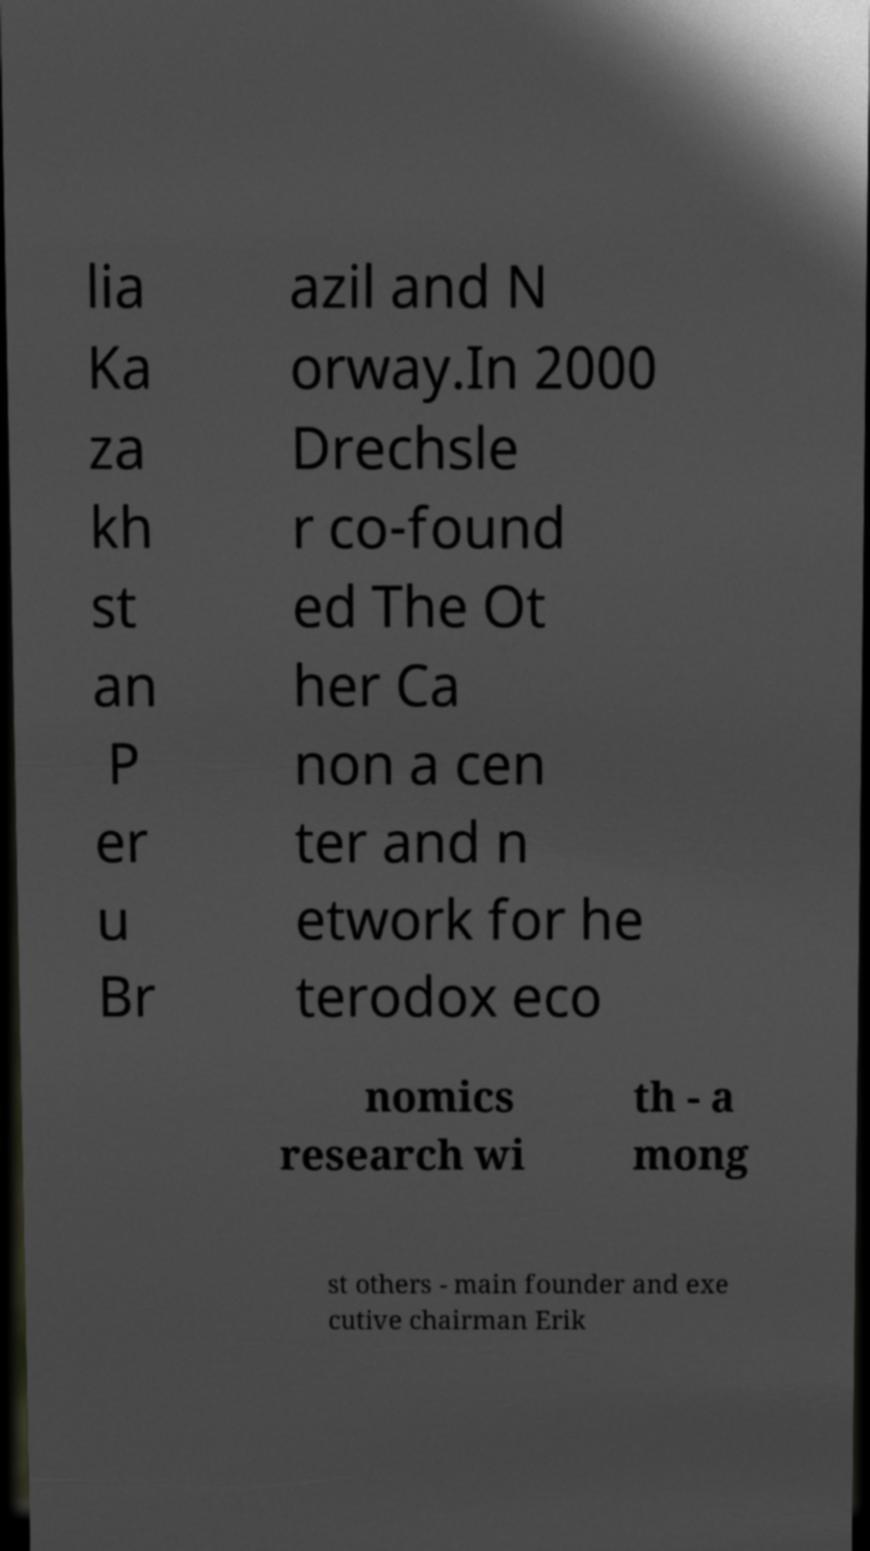Please read and relay the text visible in this image. What does it say? lia Ka za kh st an P er u Br azil and N orway.In 2000 Drechsle r co-found ed The Ot her Ca non a cen ter and n etwork for he terodox eco nomics research wi th - a mong st others - main founder and exe cutive chairman Erik 